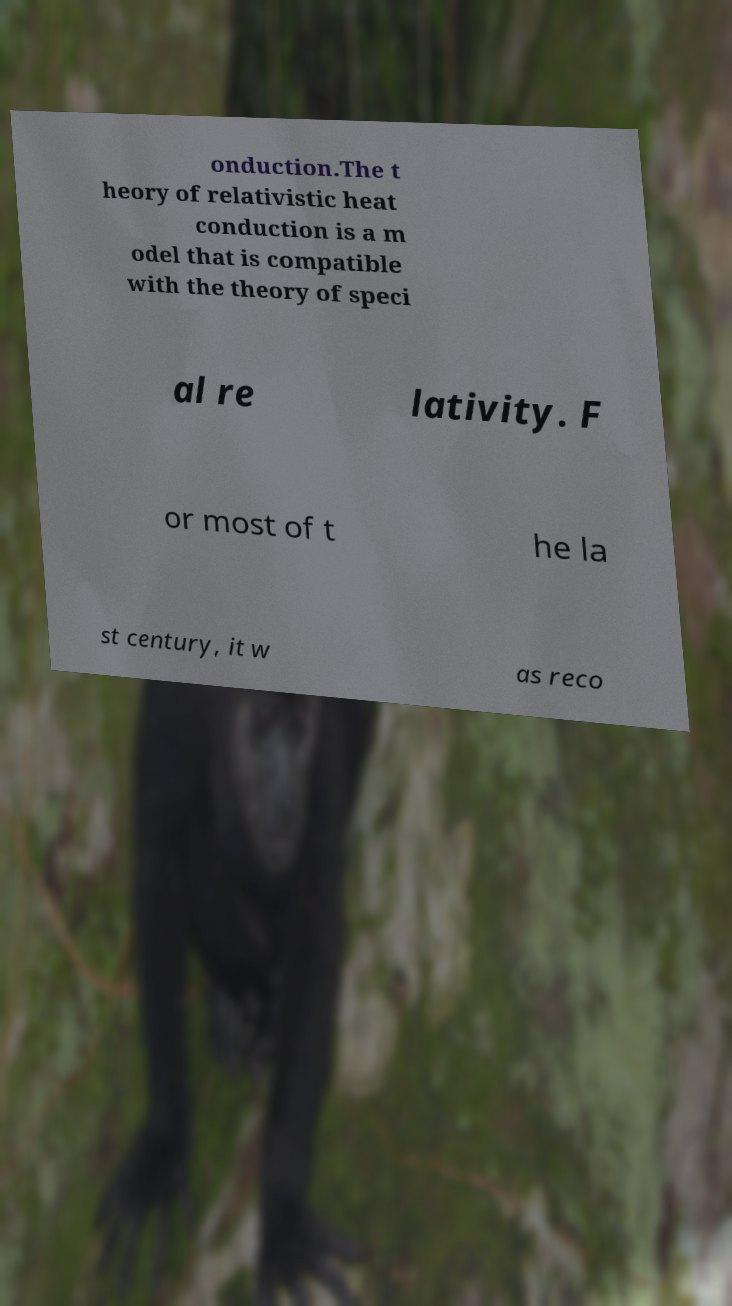I need the written content from this picture converted into text. Can you do that? onduction.The t heory of relativistic heat conduction is a m odel that is compatible with the theory of speci al re lativity. F or most of t he la st century, it w as reco 